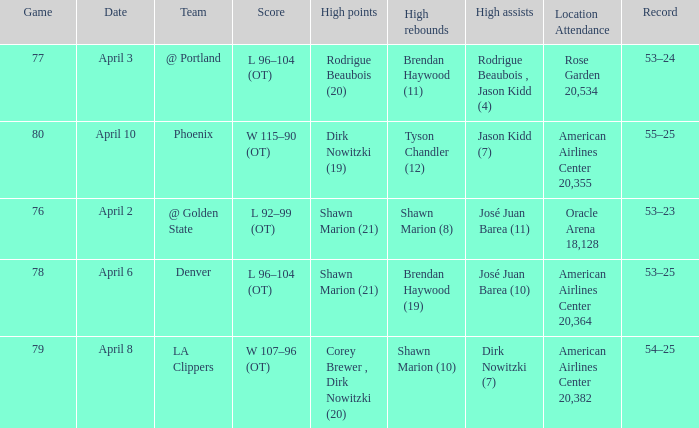What is the game number played on April 3? 77.0. 